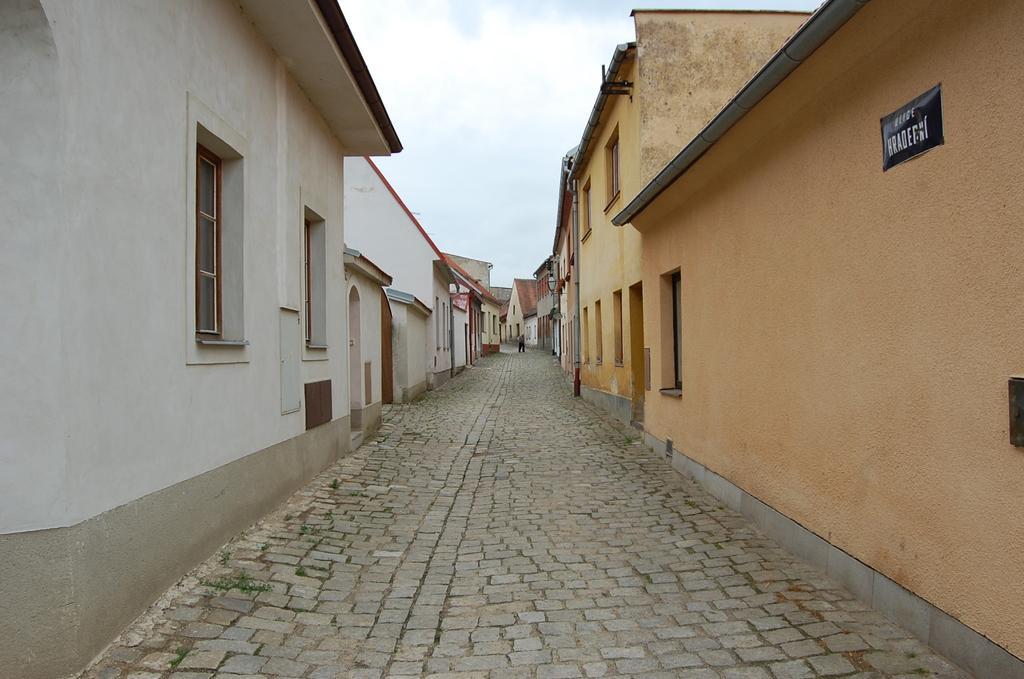How would you summarize this image in a sentence or two? Here we can see buildings and windows. Poster is on the wall. Sky is cloudy. 